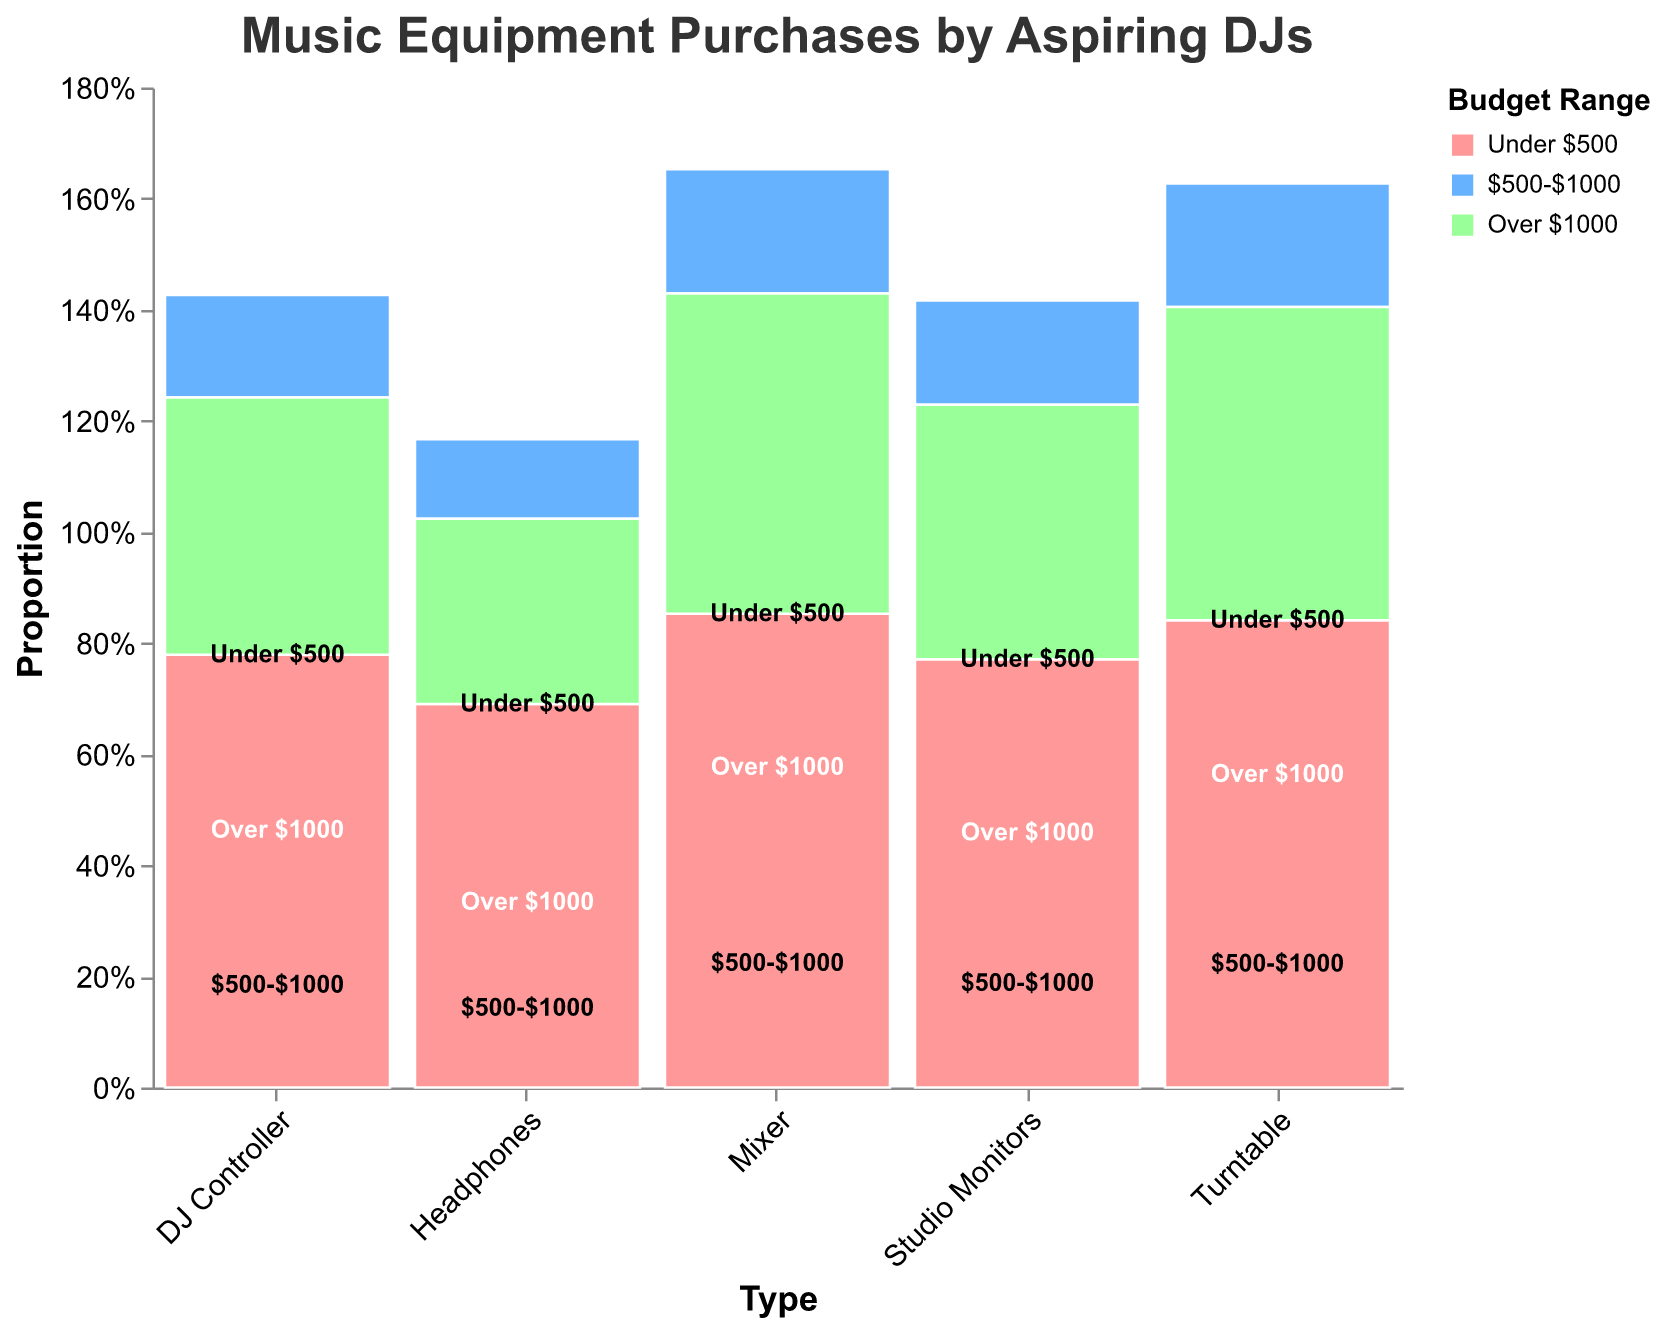How does the number of purchases for DJ Controllers in the "Under $500" range compare to the "Over $1000" range? The count for DJ Controllers in the "Under $500" range is 42, while in the "Over $1000" range it is 18. Comparing these, 42 is more than double the 18 purchases in the higher budget range.
Answer: The "Under $500" range has more purchases Which type of music equipment has the highest number of purchases in the "Under $500" budget range? The highest number of purchases for equipment under $500 is for Headphones, with a count of 65. This can be visually identified as the tallest bar segment for the "Under $500" range, colored accordingly.
Answer: Headphones Compare the total number of purchases between Mixers and Turntables. Which has more, and by how much? Mixers have a total of 85 purchases (25 + 38 + 22), whereas Turntables have a total of 63 (20 + 28 + 15). Comparing these two, Mixers have 85 - 63 = 22 more purchases.
Answer: Mixers have 22 more purchases Is the number of purchases for Studio Monitors in the "$500-$1000" range more than those for Turntables in the same range? Studio Monitors in the "$500-$1000" range have 27 purchases, while Turntables in the same range have 28. Thus, Turntables have one more purchase than Studio Monitors.
Answer: No, Turntables have more Which budget range category has the least number of purchases across all types of equipment? The "Over $1000" range has the least number of purchases across all equipment types, with all counts lower than the other ranges. The visual depiction confirms this, showing generally smaller bar segments for the "Over $1000" color.
Answer: "Over $1000" In the "Under $500" budget range, which type of equipment has the least number of purchases? How many are there? In the "Under $500" budget range, Turntables have the least number of purchases, with a count of 20. This is identified by the shortest colored bar segment labeled "Under $500".
Answer: Turntables, 20 Calculate the total number of purchases of all music equipment in the "$500-$1000" range. Adding up the purchases in the "$500-$1000" range for each equipment type: DJ Controllers (35), Headphones (30), Mixers (38), Turntables (28), and Studio Monitors (27) gives a total of 158 (35 + 30 + 38 + 28 + 27).
Answer: 158 Which type of equipment has the most varied distribution of purchases across different budget ranges? Headphones show the most varied distribution across budget ranges, with significant counts in "Under $500" (65), "$500-$1000" (30), and fewer in "Over $1000" (10). Visual inspection indicates larger disparity compared to other equipment types.
Answer: Headphones Is there any budget range where the purchases for DJ Controllers exceed those for Mixers? Yes, in the "Under $500" budget range, DJ Controllers have 42 purchases, exceeding Mixers' 25. This can be seen from longer bar segment for DJ Controllers.
Answer: Yes What proportion of the total purchases for Turntables fall in the "Over $1000" budget range? To find the proportion: 15 purchases in the "Over $1000" range divided by the total for Turntables (63). Therefore, 15/63 is approximately 0.238 or 23.8%.
Answer: 23.8% 